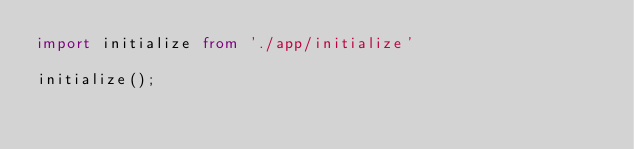<code> <loc_0><loc_0><loc_500><loc_500><_TypeScript_>import initialize from './app/initialize'

initialize();
</code> 